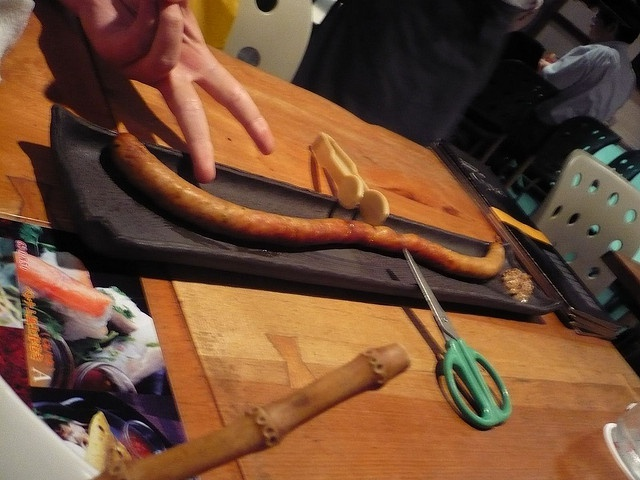Describe the objects in this image and their specific colors. I can see dining table in gray, brown, black, tan, and maroon tones, people in gray, black, and salmon tones, people in gray, maroon, salmon, brown, and tan tones, people in gray and black tones, and chair in gray and black tones in this image. 